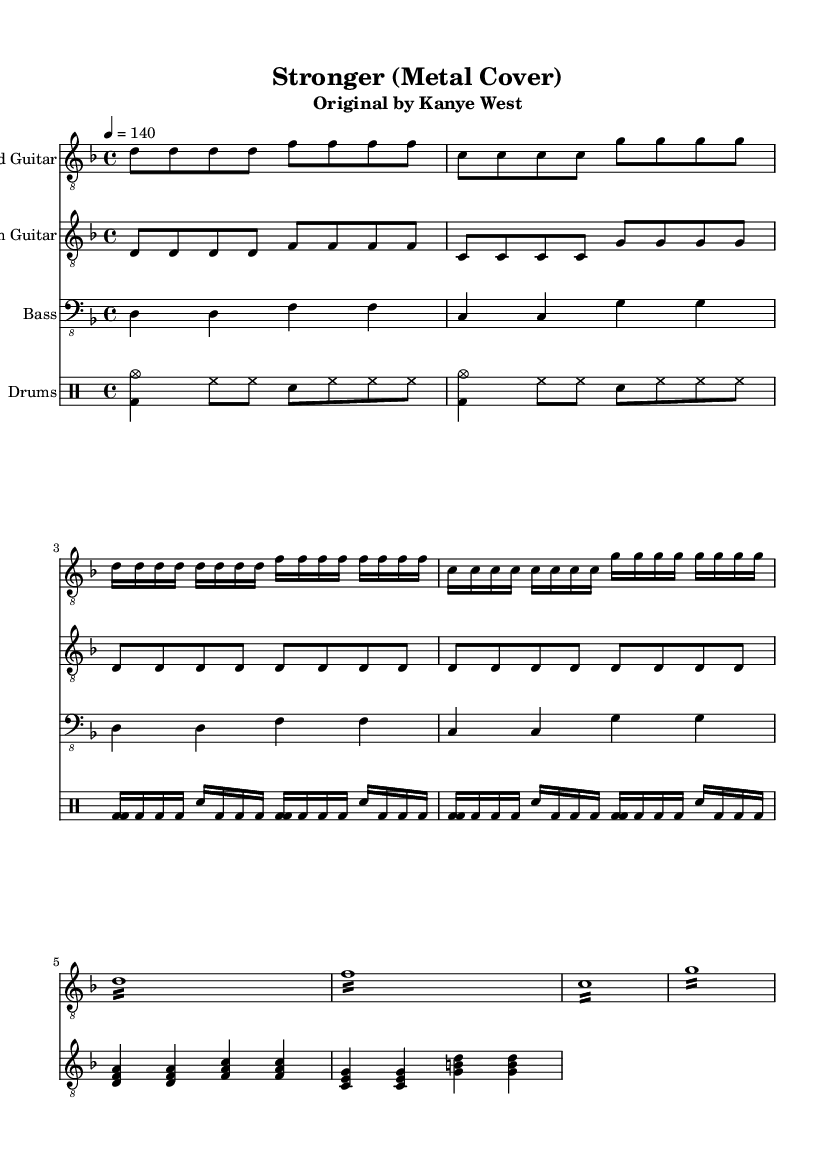What is the key signature of this music? The key signature is D minor, as indicated at the beginning of the score, which has one flat.
Answer: D minor What is the time signature of this music? The time signature is 4/4, shown at the start of the score, which means there are four beats in each measure.
Answer: 4/4 What is the tempo marking of the piece? The tempo marking is 140 beats per minute, indicated by '4 = 140', meaning each quarter note gets 140 beats.
Answer: 140 What is the starting note of the lead guitar in the intro section? The lead guitar starts on the note D, as the first note in the intro is indicated in the score.
Answer: D How many measures are in the chorus section of the lead guitar? The chorus section consists of 4 measures, calculated by counting the repetitions and measures specifically labeled in the score.
Answer: 4 What type of guitar plays the rhythm part? The rhythm part is played by the rhythm guitar, which is indicated at the beginning of that staff in the score.
Answer: Rhythm guitar What is the primary style of this cover? The primary style of this cover is metal, which is indicated by the arrangement and instrumentation choices consistent with metal music.
Answer: Metal 